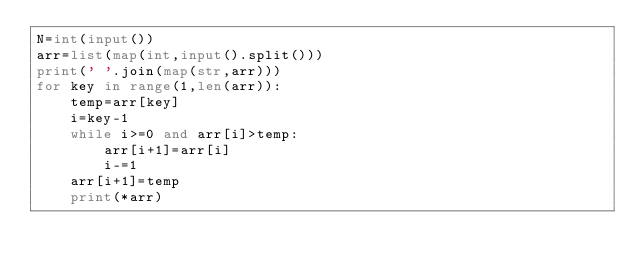<code> <loc_0><loc_0><loc_500><loc_500><_Python_>N=int(input())
arr=list(map(int,input().split()))
print(' '.join(map(str,arr)))
for key in range(1,len(arr)):
    temp=arr[key]
    i=key-1
    while i>=0 and arr[i]>temp:
        arr[i+1]=arr[i]
        i-=1
    arr[i+1]=temp
    print(*arr)</code> 